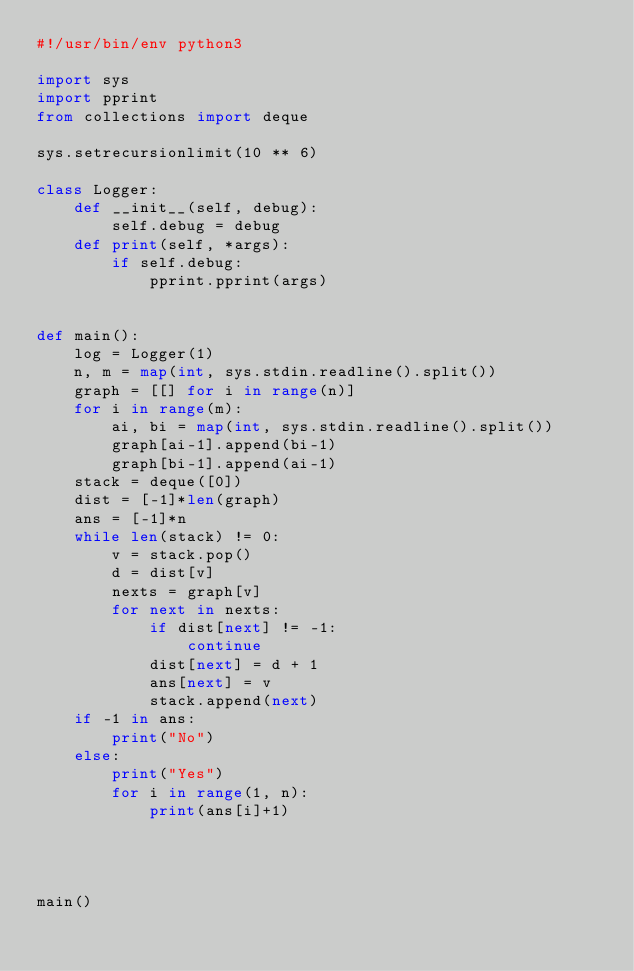<code> <loc_0><loc_0><loc_500><loc_500><_Python_>#!/usr/bin/env python3

import sys
import pprint
from collections import deque

sys.setrecursionlimit(10 ** 6)

class Logger:
	def __init__(self, debug):
		self.debug = debug
	def print(self, *args):
		if self.debug:
			pprint.pprint(args)


def main():
	log = Logger(1)
	n, m = map(int, sys.stdin.readline().split())
	graph = [[] for i in range(n)]
	for i in range(m):
		ai, bi = map(int, sys.stdin.readline().split())
		graph[ai-1].append(bi-1)
		graph[bi-1].append(ai-1)
	stack = deque([0])
	dist = [-1]*len(graph)
	ans = [-1]*n
	while len(stack) != 0:
	    v = stack.pop()
	    d = dist[v]
	    nexts = graph[v]
	    for next in nexts:
	        if dist[next] != -1:
	            continue
	        dist[next] = d + 1
	        ans[next] = v
	        stack.append(next)
	if -1 in ans:
		print("No")
	else:
		print("Yes")
		for i in range(1, n):
			print(ans[i]+1)

	


main()</code> 